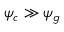<formula> <loc_0><loc_0><loc_500><loc_500>\psi _ { c } \gg \psi _ { g }</formula> 